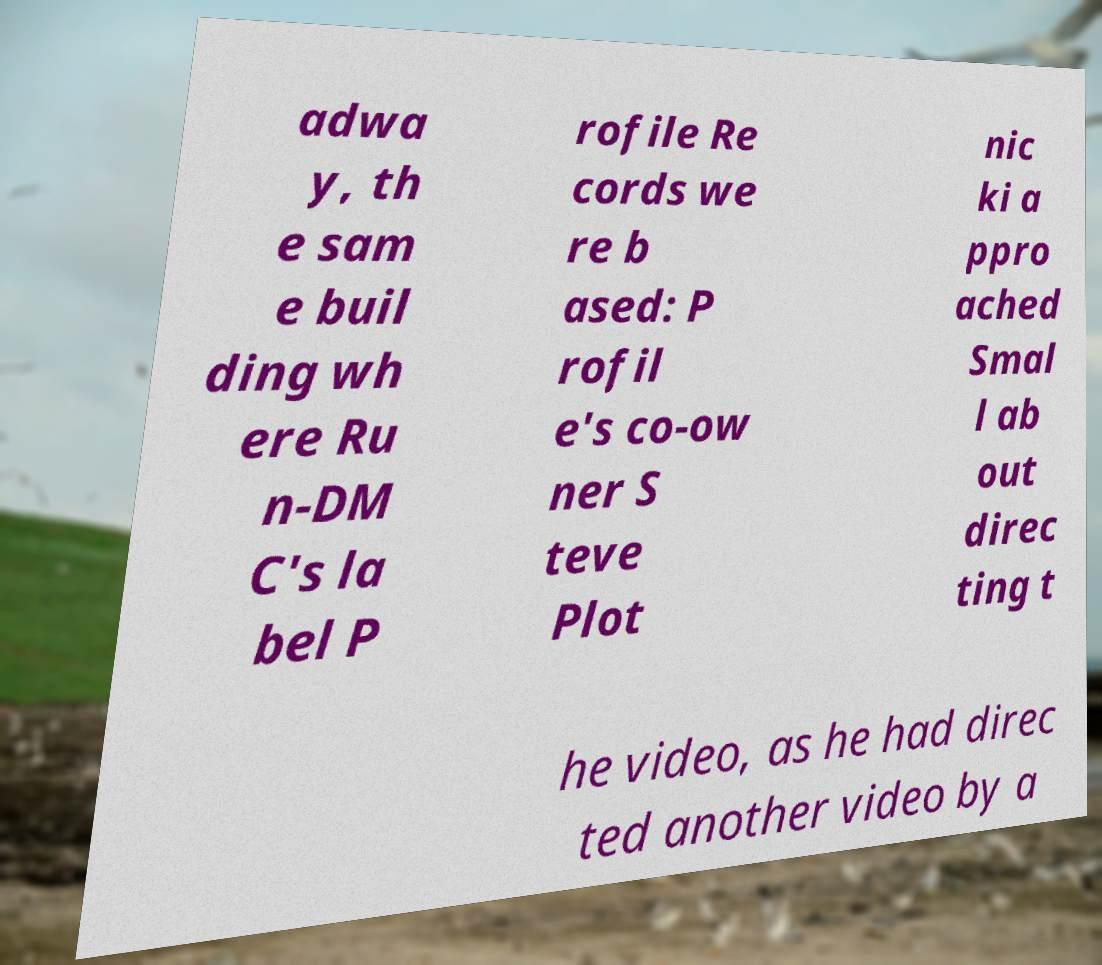What messages or text are displayed in this image? I need them in a readable, typed format. adwa y, th e sam e buil ding wh ere Ru n-DM C's la bel P rofile Re cords we re b ased: P rofil e's co-ow ner S teve Plot nic ki a ppro ached Smal l ab out direc ting t he video, as he had direc ted another video by a 